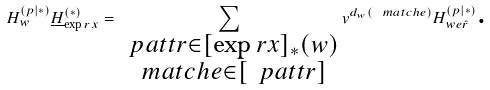Convert formula to latex. <formula><loc_0><loc_0><loc_500><loc_500>H ^ { ( p | \ast ) } _ { w } \underline { H } ^ { ( \ast ) } _ { \exp r { x } } = \sum _ { \substack { \ p a t t { r } \in [ \exp r { x } ] _ { \ast } ( w ) \\ \ m a t c h { e } \in [ \ p a t t { r } ] } } v ^ { d _ { w } ( \ m a t c h { e } ) } H ^ { ( p | \ast ) } _ { w e \hat { r } } \text {.}</formula> 